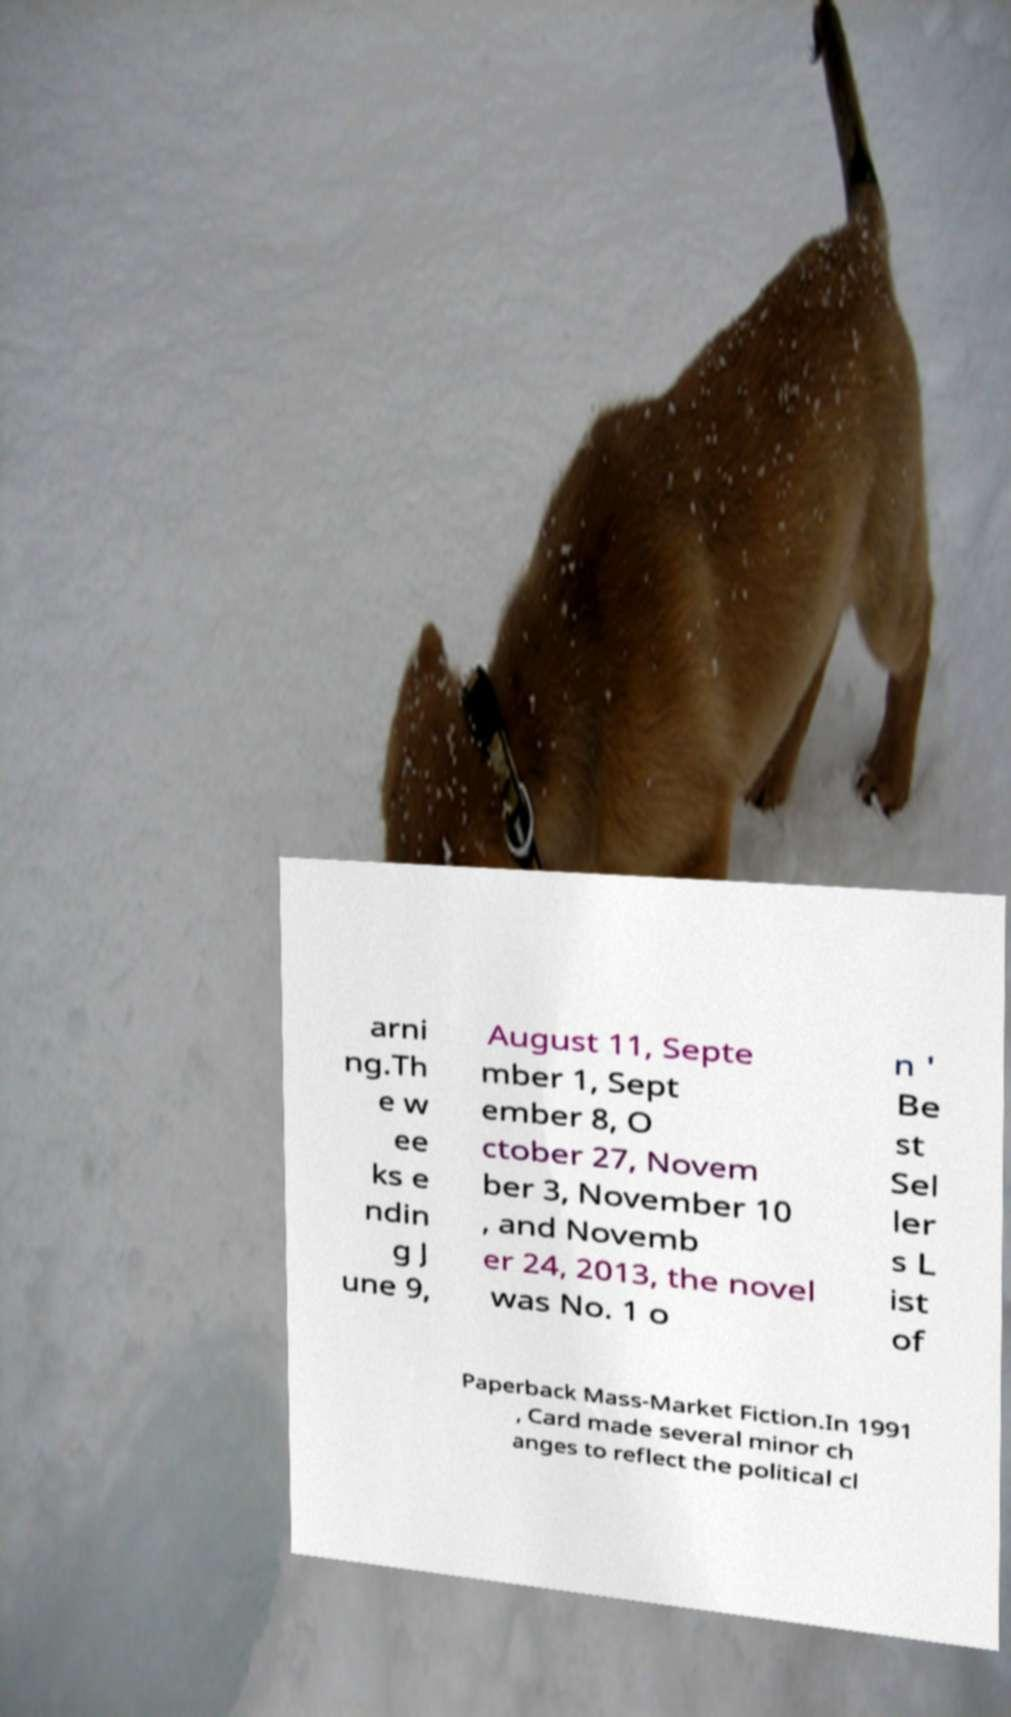Please read and relay the text visible in this image. What does it say? arni ng.Th e w ee ks e ndin g J une 9, August 11, Septe mber 1, Sept ember 8, O ctober 27, Novem ber 3, November 10 , and Novemb er 24, 2013, the novel was No. 1 o n ' Be st Sel ler s L ist of Paperback Mass-Market Fiction.In 1991 , Card made several minor ch anges to reflect the political cl 